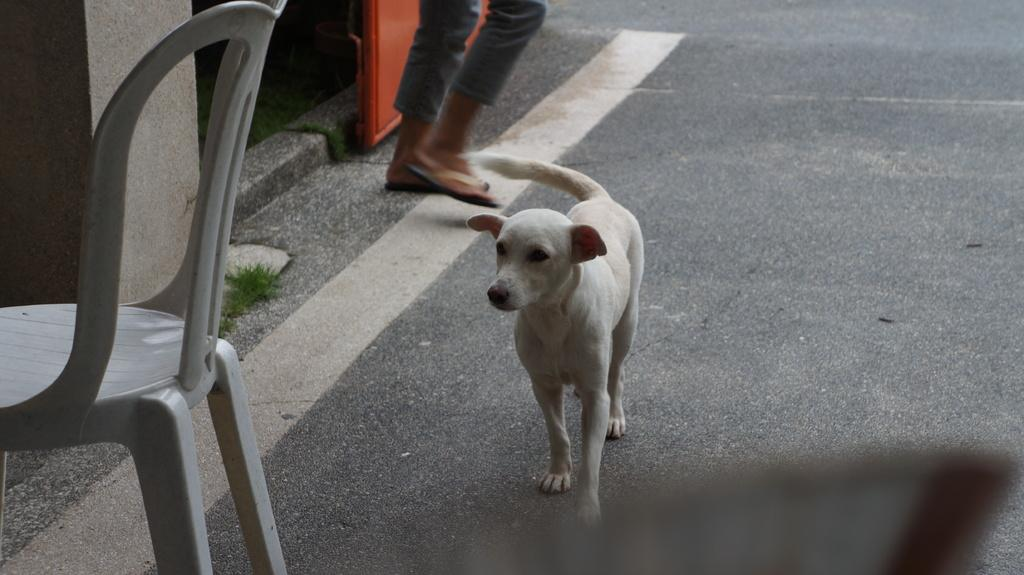What is the main subject of the image? The main subject of the image is a dog walking on the road. What can be seen on the left side of the image? There is a chair on the left side of the image. What type of vegetation is present on the side of the road? There are grasses on the side of the road. Can you identify any body parts of a person in the image? Yes, legs of a person are visible in the image. What type of letters can be seen on the dog's collar in the image? There is no mention of a collar or letters on the dog in the provided facts, so we cannot answer this question. 